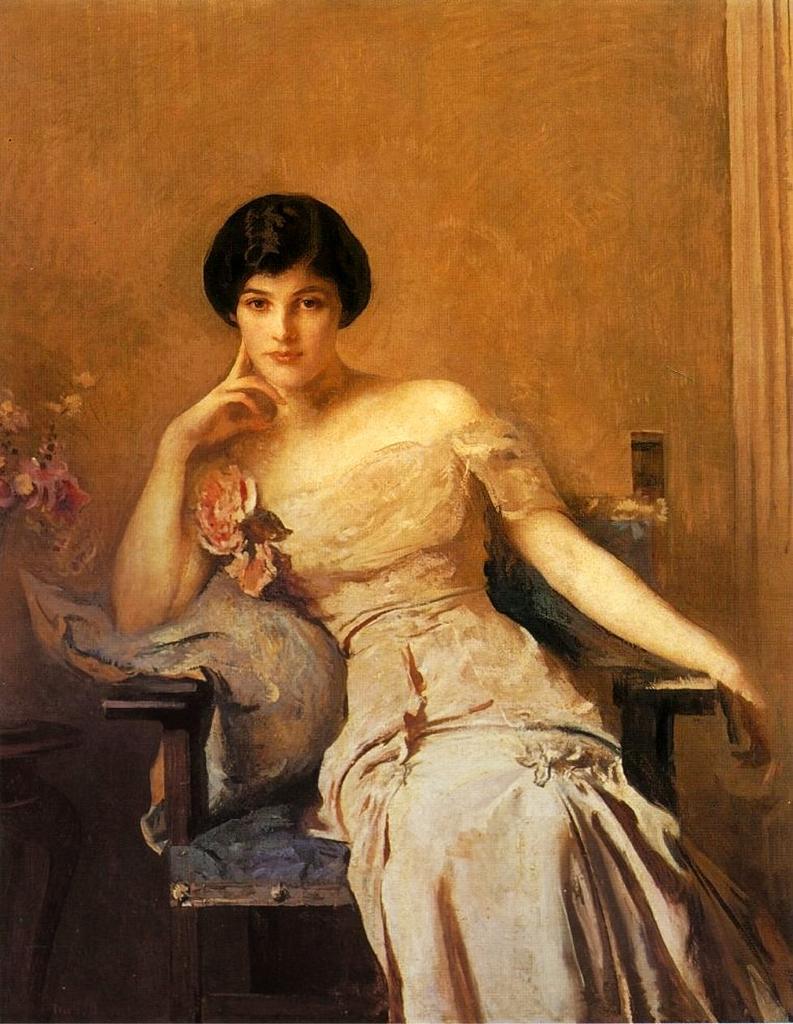Describe this image in one or two sentences. In this image, this looks like a painting. I can see the woman sitting in the chair. I think this is a flower. On the left side of the image, It looks like a table. 